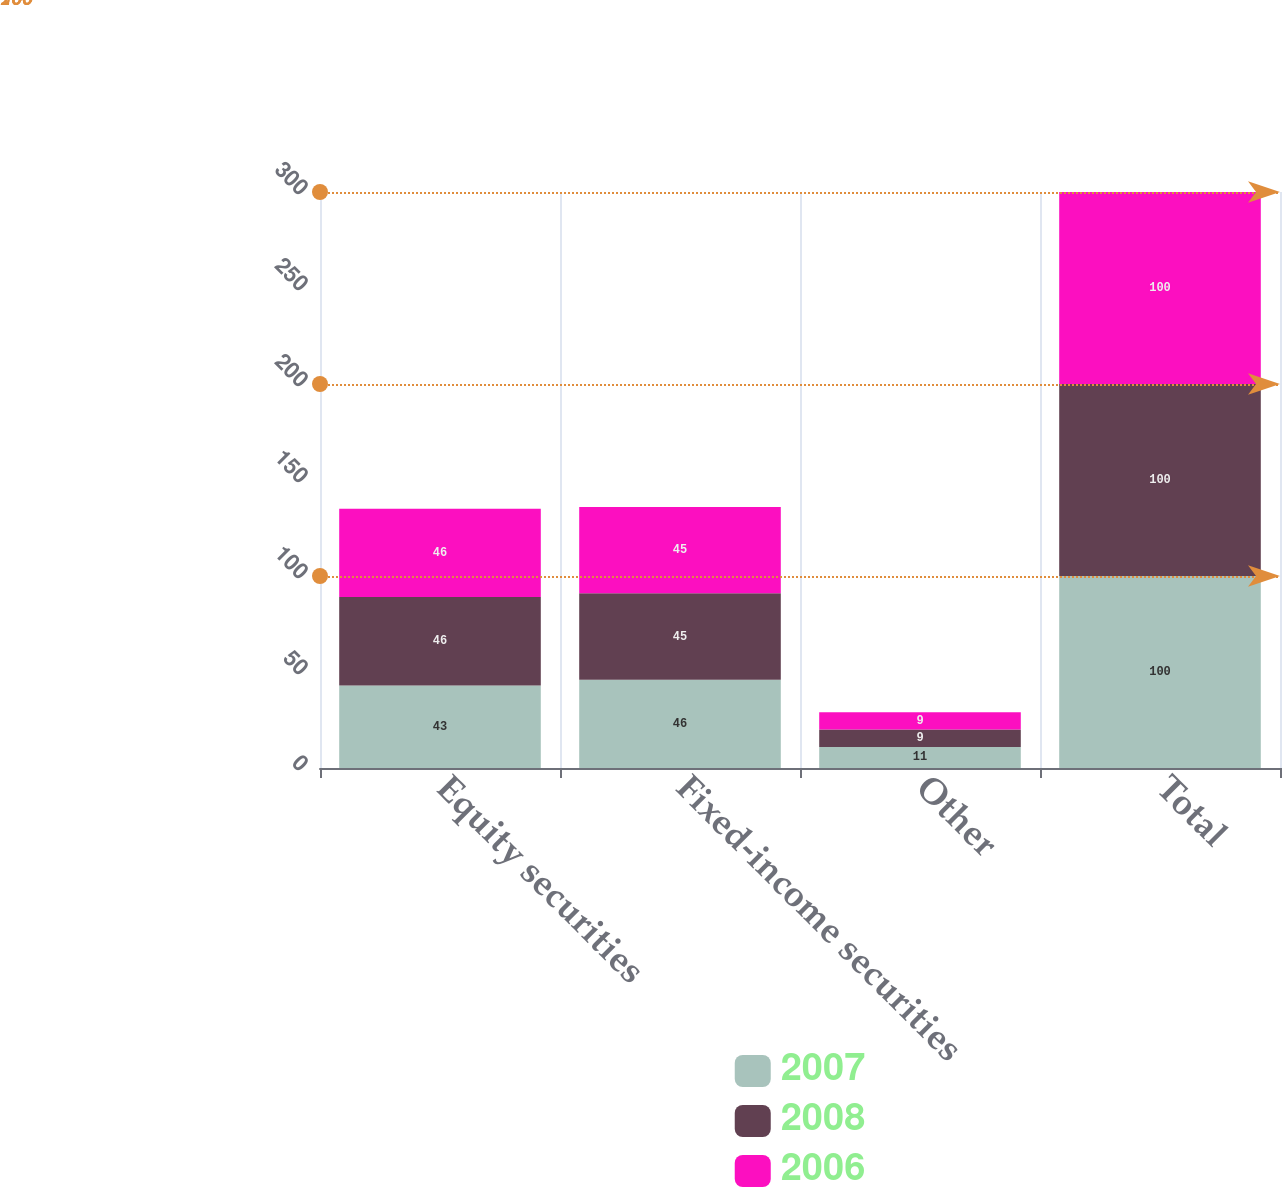Convert chart to OTSL. <chart><loc_0><loc_0><loc_500><loc_500><stacked_bar_chart><ecel><fcel>Equity securities<fcel>Fixed-income securities<fcel>Other<fcel>Total<nl><fcel>2007<fcel>43<fcel>46<fcel>11<fcel>100<nl><fcel>2008<fcel>46<fcel>45<fcel>9<fcel>100<nl><fcel>2006<fcel>46<fcel>45<fcel>9<fcel>100<nl></chart> 